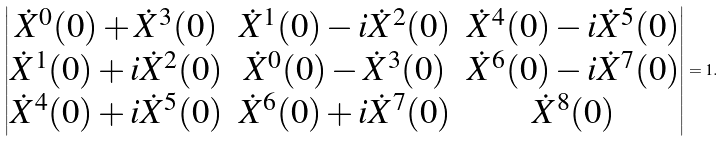<formula> <loc_0><loc_0><loc_500><loc_500>\begin{vmatrix} \dot { X } ^ { 0 } ( 0 ) + \dot { X } ^ { 3 } ( 0 ) & \dot { X } ^ { 1 } ( 0 ) - i \dot { X } ^ { 2 } ( 0 ) & \dot { X } ^ { 4 } ( 0 ) - i \dot { X } ^ { 5 } ( 0 ) \\ \dot { X } ^ { 1 } ( 0 ) + i \dot { X } ^ { 2 } ( 0 ) & \dot { X } ^ { 0 } ( 0 ) - \dot { X } ^ { 3 } ( 0 ) & \dot { X } ^ { 6 } ( 0 ) - i \dot { X } ^ { 7 } ( 0 ) \\ \dot { X } ^ { 4 } ( 0 ) + i \dot { X } ^ { 5 } ( 0 ) & \dot { X } ^ { 6 } ( 0 ) + i \dot { X } ^ { 7 } ( 0 ) & \dot { X } ^ { 8 } ( 0 ) \end{vmatrix} = 1 .</formula> 